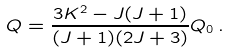Convert formula to latex. <formula><loc_0><loc_0><loc_500><loc_500>Q = \frac { 3 K ^ { 2 } - J ( J + 1 ) } { ( J + 1 ) ( 2 J + 3 ) } Q _ { 0 } \, .</formula> 